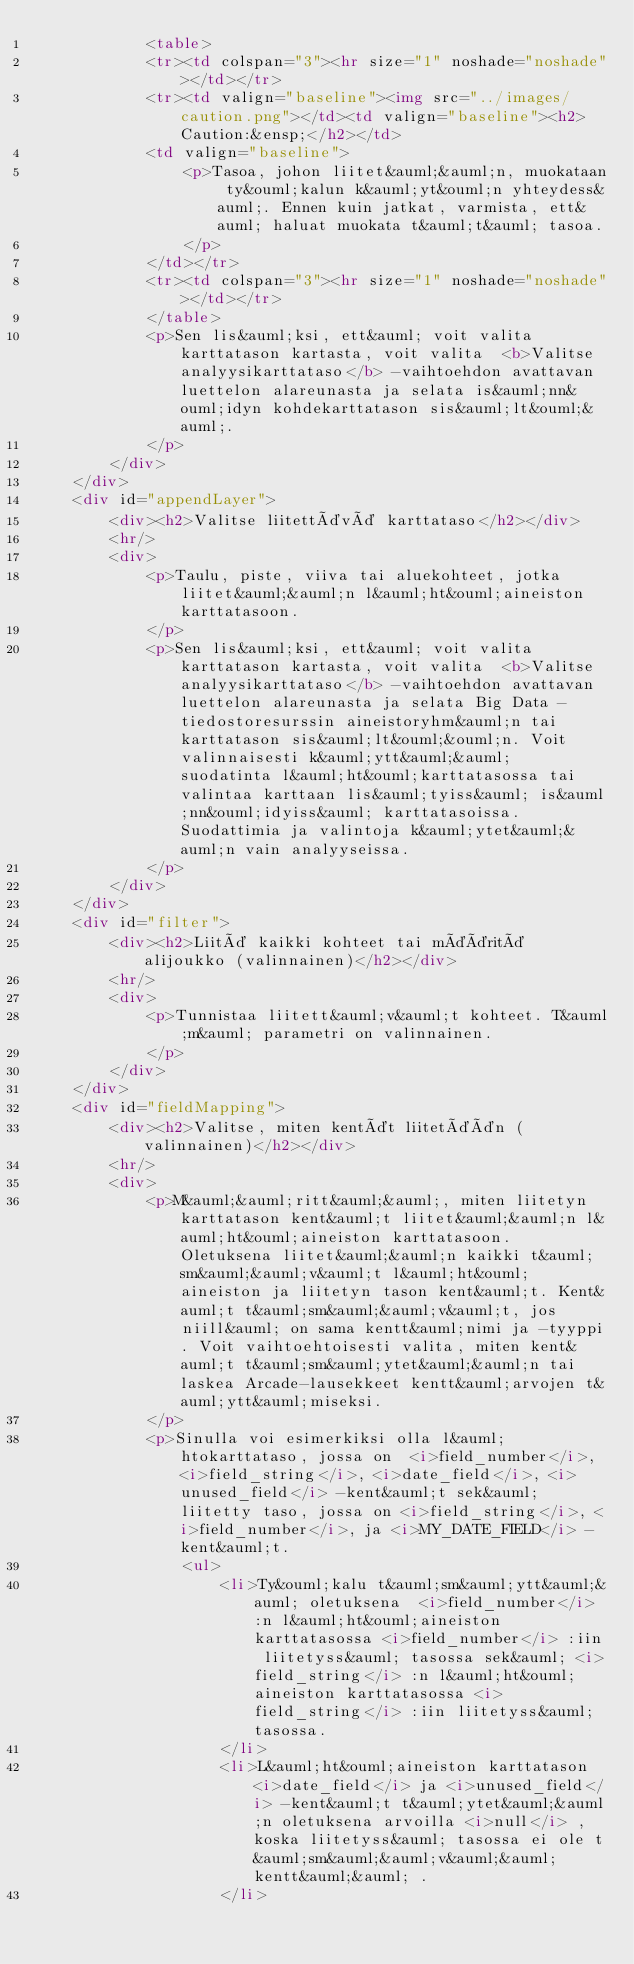<code> <loc_0><loc_0><loc_500><loc_500><_HTML_>            <table>
            <tr><td colspan="3"><hr size="1" noshade="noshade"></td></tr>
            <tr><td valign="baseline"><img src="../images/caution.png"></td><td valign="baseline"><h2>Caution:&ensp;</h2></td>
            <td valign="baseline">
                <p>Tasoa, johon liitet&auml;&auml;n, muokataan ty&ouml;kalun k&auml;yt&ouml;n yhteydess&auml;. Ennen kuin jatkat, varmista, ett&auml; haluat muokata t&auml;t&auml; tasoa.
                </p>
            </td></tr>
            <tr><td colspan="3"><hr size="1" noshade="noshade"></td></tr>
            </table>
            <p>Sen lis&auml;ksi, ett&auml; voit valita karttatason kartasta, voit valita  <b>Valitse analyysikarttataso</b> -vaihtoehdon avattavan luettelon alareunasta ja selata is&auml;nn&ouml;idyn kohdekarttatason sis&auml;lt&ouml;&auml;. 
            </p>
        </div>
    </div>
    <div id="appendLayer">
        <div><h2>Valitse liitettävä karttataso</h2></div>
        <hr/>
        <div>
            <p>Taulu, piste, viiva tai aluekohteet, jotka liitet&auml;&auml;n l&auml;ht&ouml;aineiston karttatasoon.
            </p>
            <p>Sen lis&auml;ksi, ett&auml; voit valita karttatason kartasta, voit valita  <b>Valitse analyysikarttataso</b> -vaihtoehdon avattavan luettelon alareunasta ja selata Big Data -tiedostoresurssin aineistoryhm&auml;n tai karttatason sis&auml;lt&ouml;&ouml;n. Voit valinnaisesti k&auml;ytt&auml;&auml; suodatinta l&auml;ht&ouml;karttatasossa tai valintaa karttaan lis&auml;tyiss&auml; is&auml;nn&ouml;idyiss&auml; karttatasoissa. Suodattimia ja valintoja k&auml;ytet&auml;&auml;n vain analyyseissa. 
            </p>
        </div>
    </div>
    <div id="filter">
        <div><h2>Liitä kaikki kohteet tai määritä alijoukko (valinnainen)</h2></div>
        <hr/>
        <div>
            <p>Tunnistaa liitett&auml;v&auml;t kohteet. T&auml;m&auml; parametri on valinnainen.
            </p>
        </div>
    </div>
    <div id="fieldMapping">
        <div><h2>Valitse, miten kentät liitetään (valinnainen)</h2></div>
        <hr/>
        <div>
            <p>M&auml;&auml;ritt&auml;&auml;, miten liitetyn karttatason kent&auml;t liitet&auml;&auml;n l&auml;ht&ouml;aineiston karttatasoon. Oletuksena liitet&auml;&auml;n kaikki t&auml;sm&auml;&auml;v&auml;t l&auml;ht&ouml;aineiston ja liitetyn tason kent&auml;t. Kent&auml;t t&auml;sm&auml;&auml;v&auml;t, jos niill&auml; on sama kentt&auml;nimi ja -tyyppi. Voit vaihtoehtoisesti valita, miten kent&auml;t t&auml;sm&auml;ytet&auml;&auml;n tai laskea Arcade-lausekkeet kentt&auml;arvojen t&auml;ytt&auml;miseksi.
            </p>
            <p>Sinulla voi esimerkiksi olla l&auml;htokarttataso, jossa on  <i>field_number</i>, <i>field_string</i>, <i>date_field</i>, <i>unused_field</i> -kent&auml;t sek&auml; liitetty taso, jossa on <i>field_string</i>, <i>field_number</i>, ja <i>MY_DATE_FIELD</i> -kent&auml;t.
                <ul>
                    <li>Ty&ouml;kalu t&auml;sm&auml;ytt&auml;&auml; oletuksena  <i>field_number</i> :n l&auml;ht&ouml;aineiston karttatasossa <i>field_number</i> :iin liitetyss&auml; tasossa sek&auml; <i>field_string</i> :n l&auml;ht&ouml;aineiston karttatasossa <i>field_string</i> :iin liitetyss&auml; tasossa.
                    </li>
                    <li>L&auml;ht&ouml;aineiston karttatason  <i>date_field</i> ja <i>unused_field</i> -kent&auml;t t&auml;ytet&auml;&auml;n oletuksena arvoilla <i>null</i> , koska liitetyss&auml; tasossa ei ole t&auml;sm&auml;&auml;v&auml;&auml; kentt&auml;&auml; .
                    </li></code> 